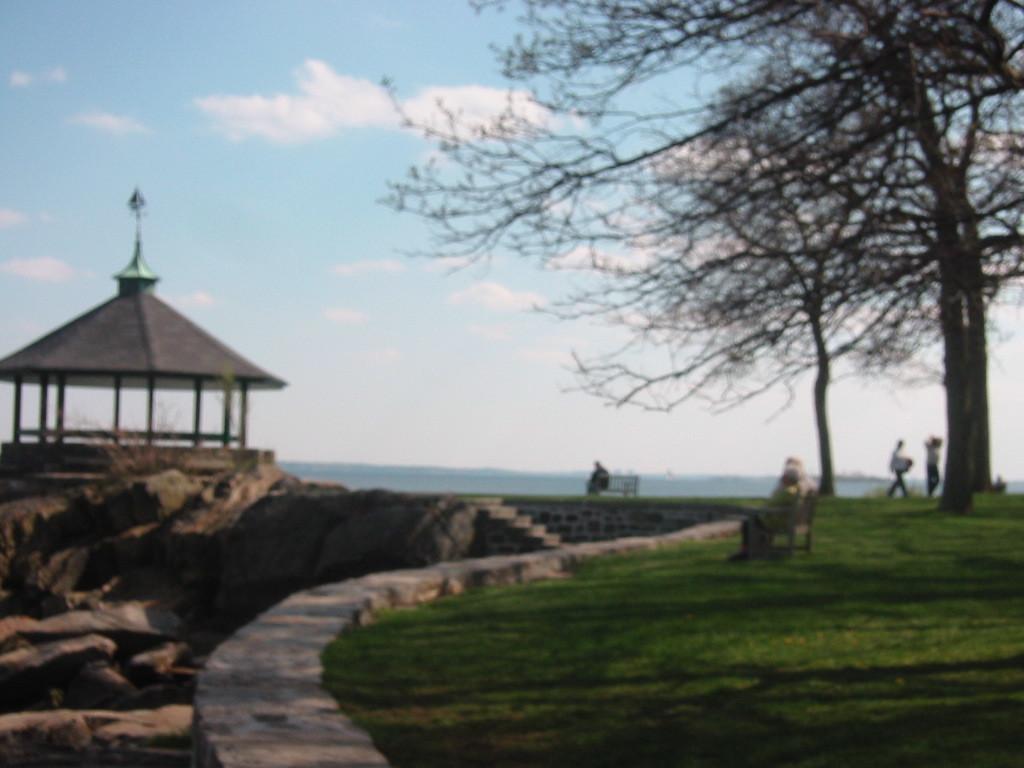Could you give a brief overview of what you see in this image? In the image I can see few dry trees, few people, shed, stones, stairs, grass and few people are sitting on the benches. The sky is in white and blue color. 